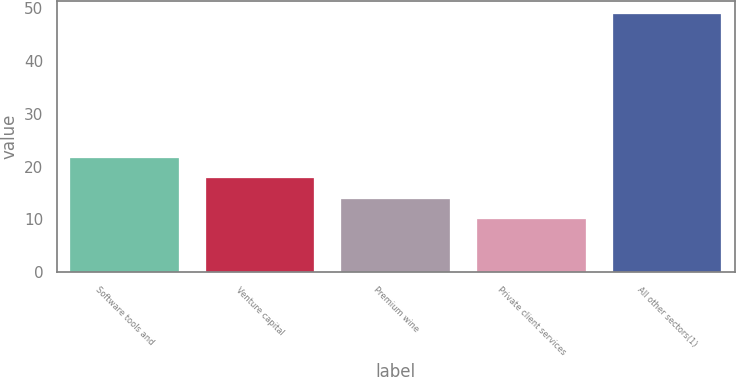<chart> <loc_0><loc_0><loc_500><loc_500><bar_chart><fcel>Software tools and<fcel>Venture capital<fcel>Premium wine<fcel>Private client services<fcel>All other sectors(1)<nl><fcel>21.67<fcel>17.78<fcel>13.89<fcel>10<fcel>48.9<nl></chart> 